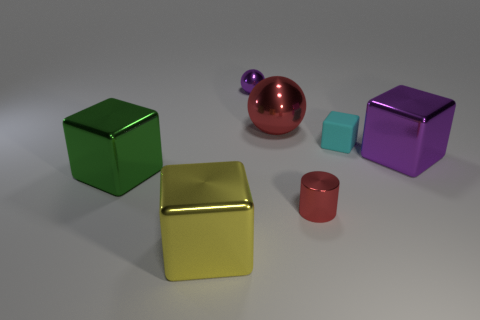Subtract 1 blocks. How many blocks are left? 3 Add 3 yellow matte objects. How many objects exist? 10 Subtract all gray cubes. Subtract all cyan spheres. How many cubes are left? 4 Subtract all cubes. How many objects are left? 3 Add 4 small cyan objects. How many small cyan objects are left? 5 Add 6 big red shiny objects. How many big red shiny objects exist? 7 Subtract 0 green cylinders. How many objects are left? 7 Subtract all tiny red cylinders. Subtract all big brown shiny things. How many objects are left? 6 